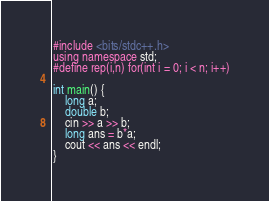Convert code to text. <code><loc_0><loc_0><loc_500><loc_500><_C++_>#include <bits/stdc++.h>
using namespace std;
#define rep(i,n) for(int i = 0; i < n; i++)

int main() {
    long a;
    double b;
    cin >> a >> b;
    long ans = b*a;
    cout << ans << endl;
}
</code> 